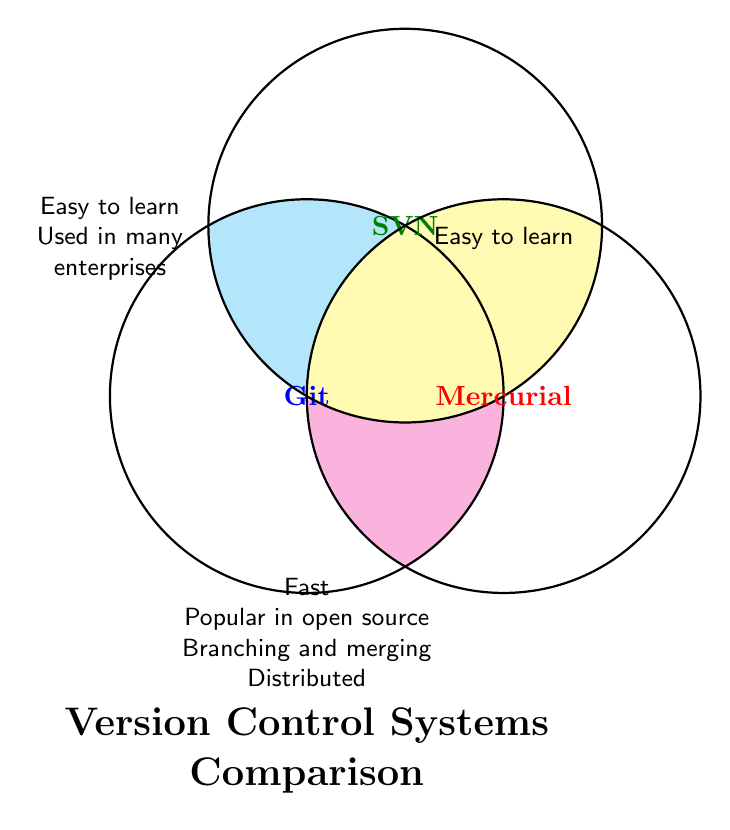How many version control systems are in this comparison? The diagram shows three labeled circles, each representing one version control system: Git, SVN, and Mercurial.
Answer: 3 Which version control systems are described as "Easy to learn"? The circles representing "Easy to learn" intersect with both Git and SVN.
Answer: Git, SVN Which two version control systems are both "Distributed"? The "Distributed" property intersects with the Git and Mercurial circles.
Answer: Git, Mercurial Which version control system is noted as being "Used in many enterprises"? "Used in many enterprises" intersects with both Git and SVN.
Answer: Git, SVN What features are unique to Git and Mercurial jointly? The intersection of the Git and Mercurial circles without overlapping with the SVN circle lists: "Fast," "Popular in open source," "Branching and merging," and "Distributed."
Answer: Fast, Popular in open source, Branching and merging, Distributed Is SVN marked as "Popular in open source"? The "Popular in open source" feature does not intersect with the SVN circle.
Answer: No List all features shared by Git, SVN, and Mercurial. The center intersection where Git, SVN, and Mercurial overlap does not contain any feature labels.
Answer: None Which system is easy to learn but not marked as being "Used in many enterprises"? The feature "Easy to learn" intersects with both Git and SVN individually in separate intersections; however, when considering SVN and "Used in many enterprises," "Easy to learn" stands alone for just Git.
Answer: None 